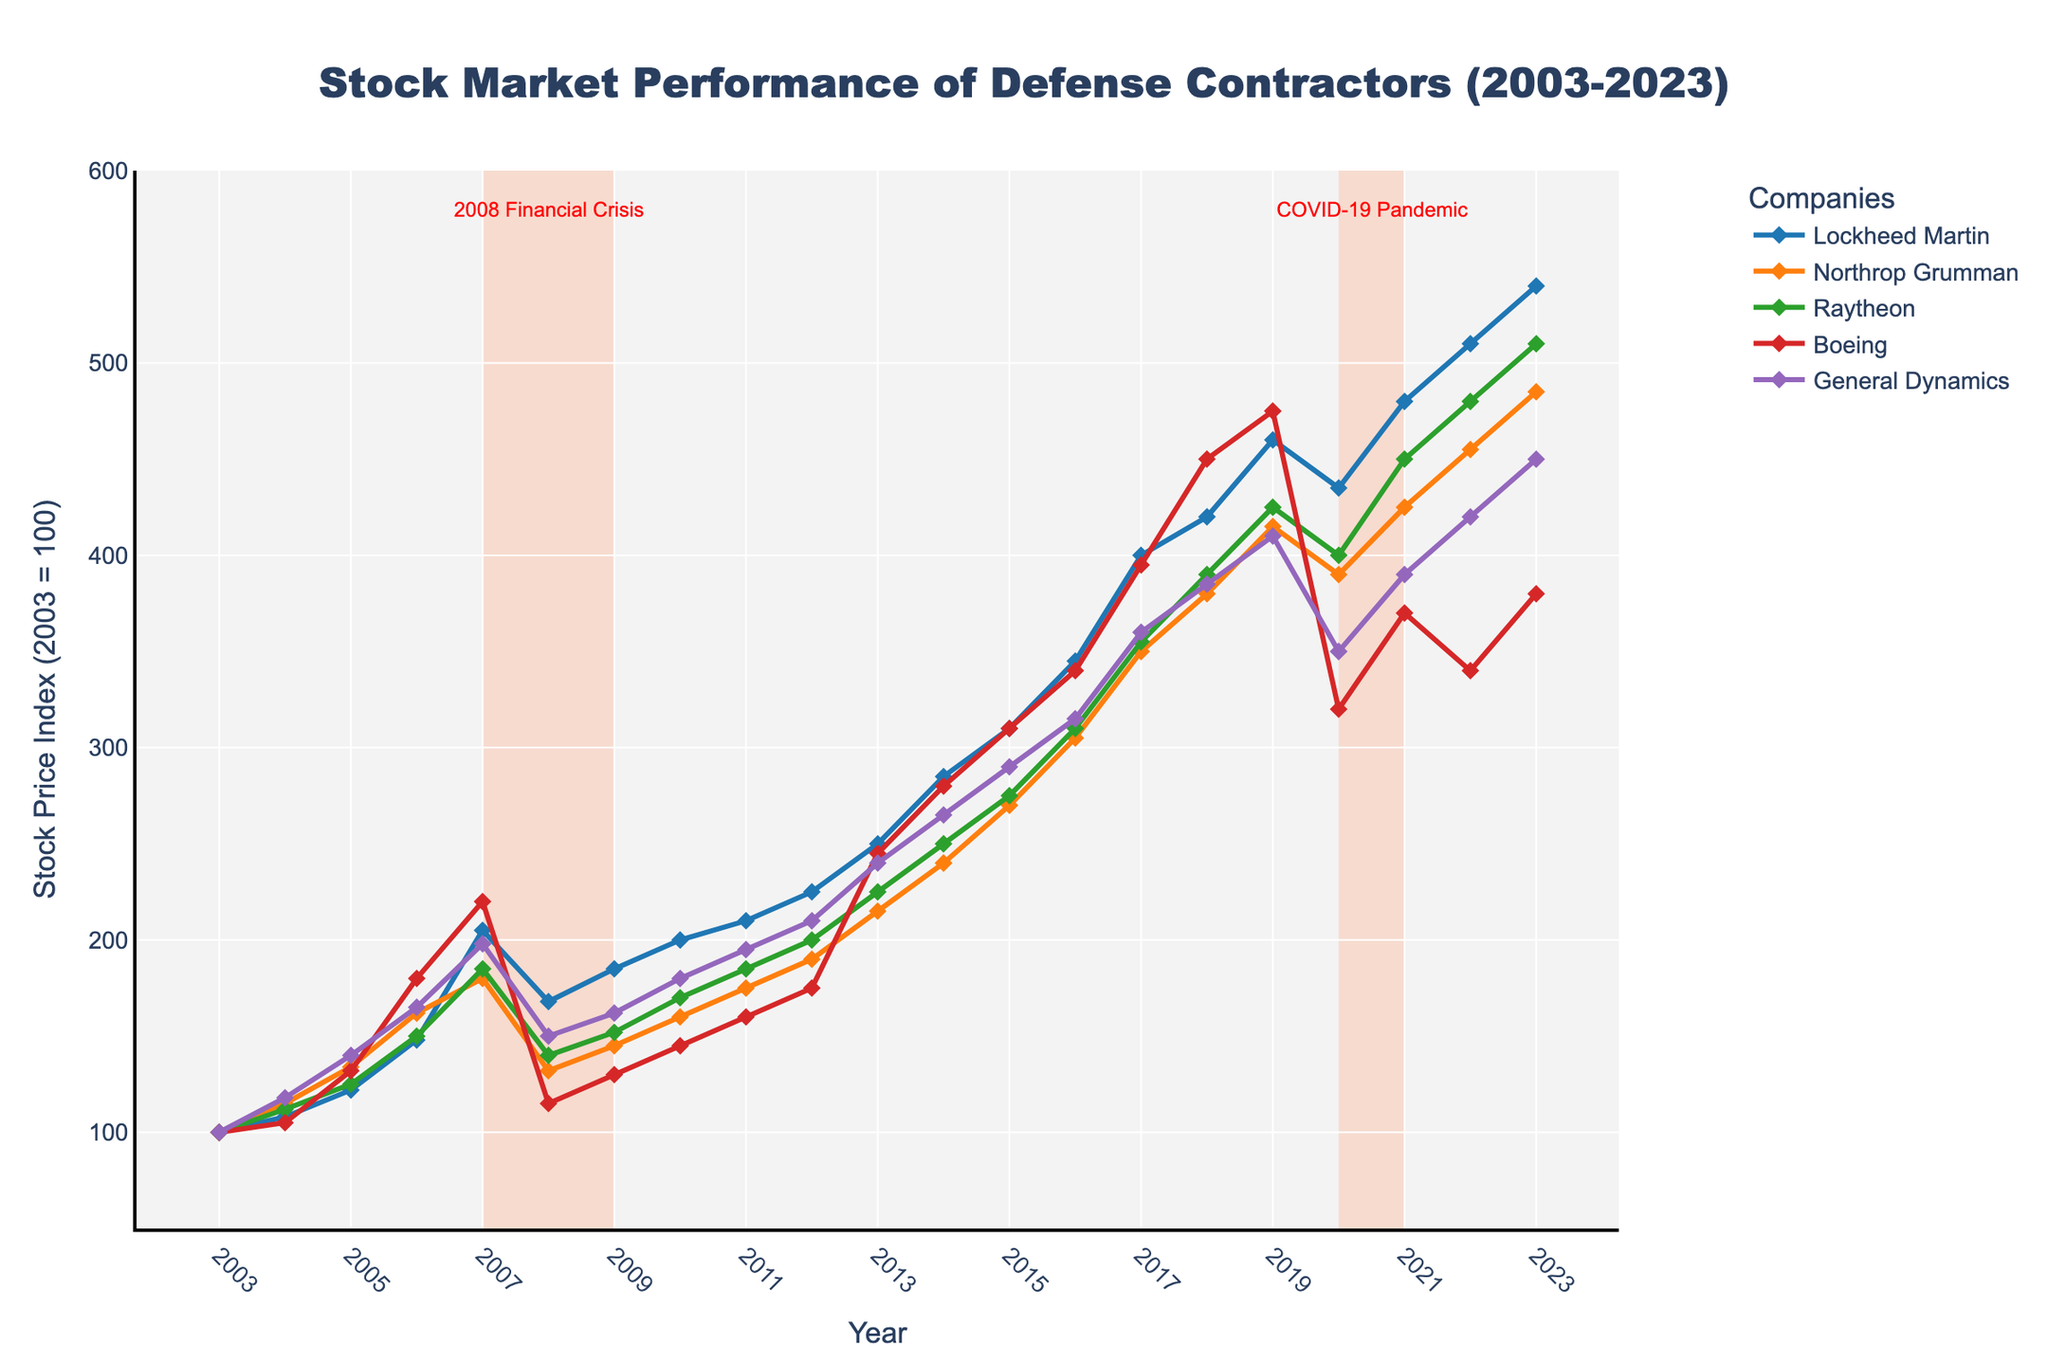What year did Lockheed Martin's stock price index first surpass 400? Locate the line representing Lockheed Martin and find the year where its stock index value first exceeds 400. This occurs in 2017.
Answer: 2017 Which company had the highest stock price index in 2023? Compare the stock price index values for all companies in 2023 and identify the highest one. Lockheed Martin had the highest.
Answer: Lockheed Martin What was the approximate stock price index difference between Boeing and General Dynamics in 2018? Subtract the stock price index of General Dynamics from that of Boeing in 2018. The difference is 450 - 385.
Answer: 65 During the COVID-19 Pandemic recession period, which company showed the largest decline from 2019 to 2020? Identify the stock price index for each company in 2019 and 2020, and calculate the decline for each. Boeing showed the largest decline from 475 to 320.
Answer: Boeing How many companies had a stock price index of 400 or more by the year 2017? Check the stock price indexes for all companies in 2017 and count those that are 400 or higher. Three companies meet this criterion: Lockheed Martin, Northrop Grumman, and Raytheon.
Answer: 3 What was the highest stock price index reached by Northrop Grumman over the entire period? Scan the values for Northrop Grumman from 2003 to 2023 and identify the highest value, which is 485 in 2023.
Answer: 485 Which company had the lowest stock price index during the 2008 Financial Crisis, and what was the value? Look at the stock price indexes for all companies in 2008 and find the lowest value. Northrop Grumman had the lowest at 132.
Answer: Northrop Grumman, 132 What is the average stock price index of General Dynamics from 2003 to 2013? Add the stock price indexes for General Dynamics from 2003 to 2013 and divide by the number of years. The average is (100+118+140+165+198+150+162+180+195+210+240)/11 ≈ 174.64.
Answer: 174.64 What was the trend for Raytheon's stock price index from 2006 to 2008 and then from 2008 to 2010? Observe the values for Raytheon from 2006 to 2008 (150 to 140) to see a decline, and from 2008 to 2010 (140 to 170) to see an incline. The trend is first a decline, then an incline.
Answer: First decline, then incline Which year showed the highest stock price index for Lockheed Martin, and what was the value? Compare the stock price indexes for Lockheed Martin from 2003 to 2023 and identify the highest value, which is 540 in 2023.
Answer: 2023, 540 